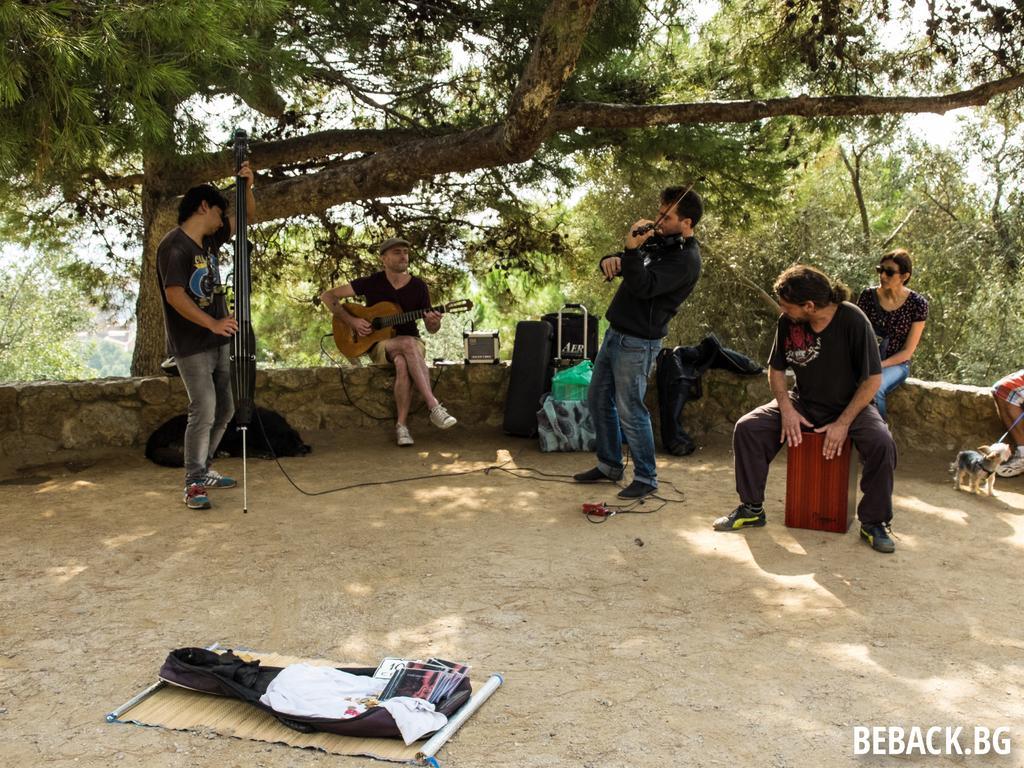Could you give a brief overview of what you see in this image? In the image there are five people four man and woman. Who is sitting on stone and wearing her goggles on right side there is a little dog on left side there is another dog who is lying on land. In middle there is a man who is playing his guitar and on the left side there is another man who is playing his violin. On land we can see mat on mat there are some clothes and books in background there are trees and sky on top. 